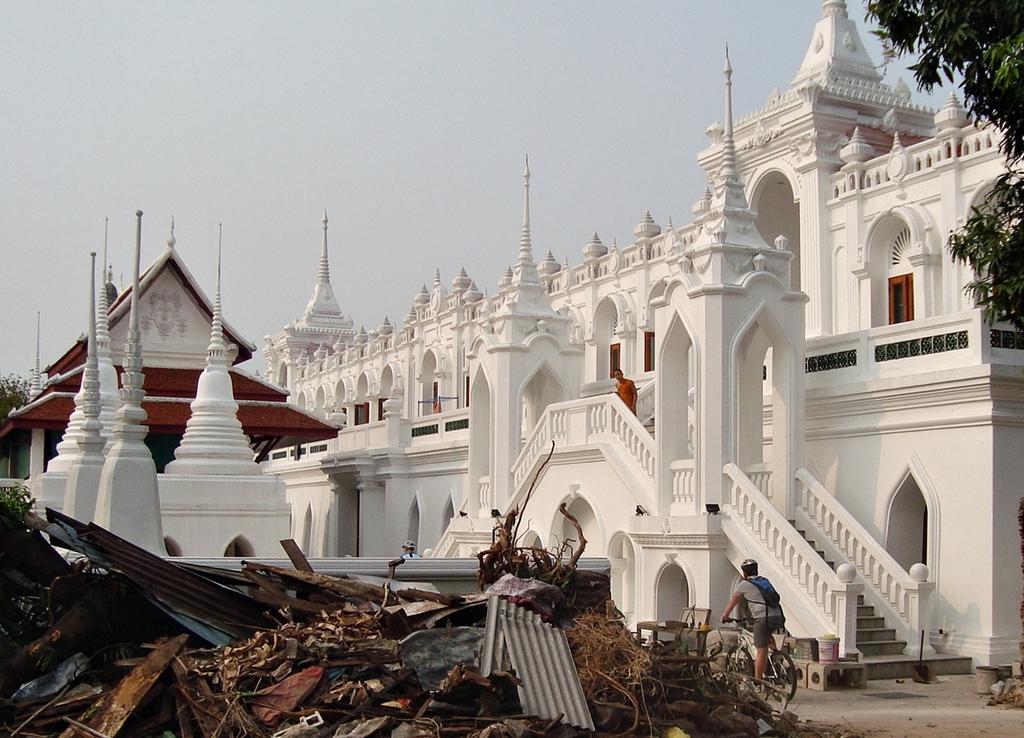Can you describe this image briefly? In this image there is a white color building , on which there is a person standing, in front of the of the building, there is a person riding on bicycle visible in the middle, at the bottom there are metal objects, wires , wooden planks, kept on the floor, on the left side there is a small tent house, at the top there is the sky, in the top right there are some leaves visible. 